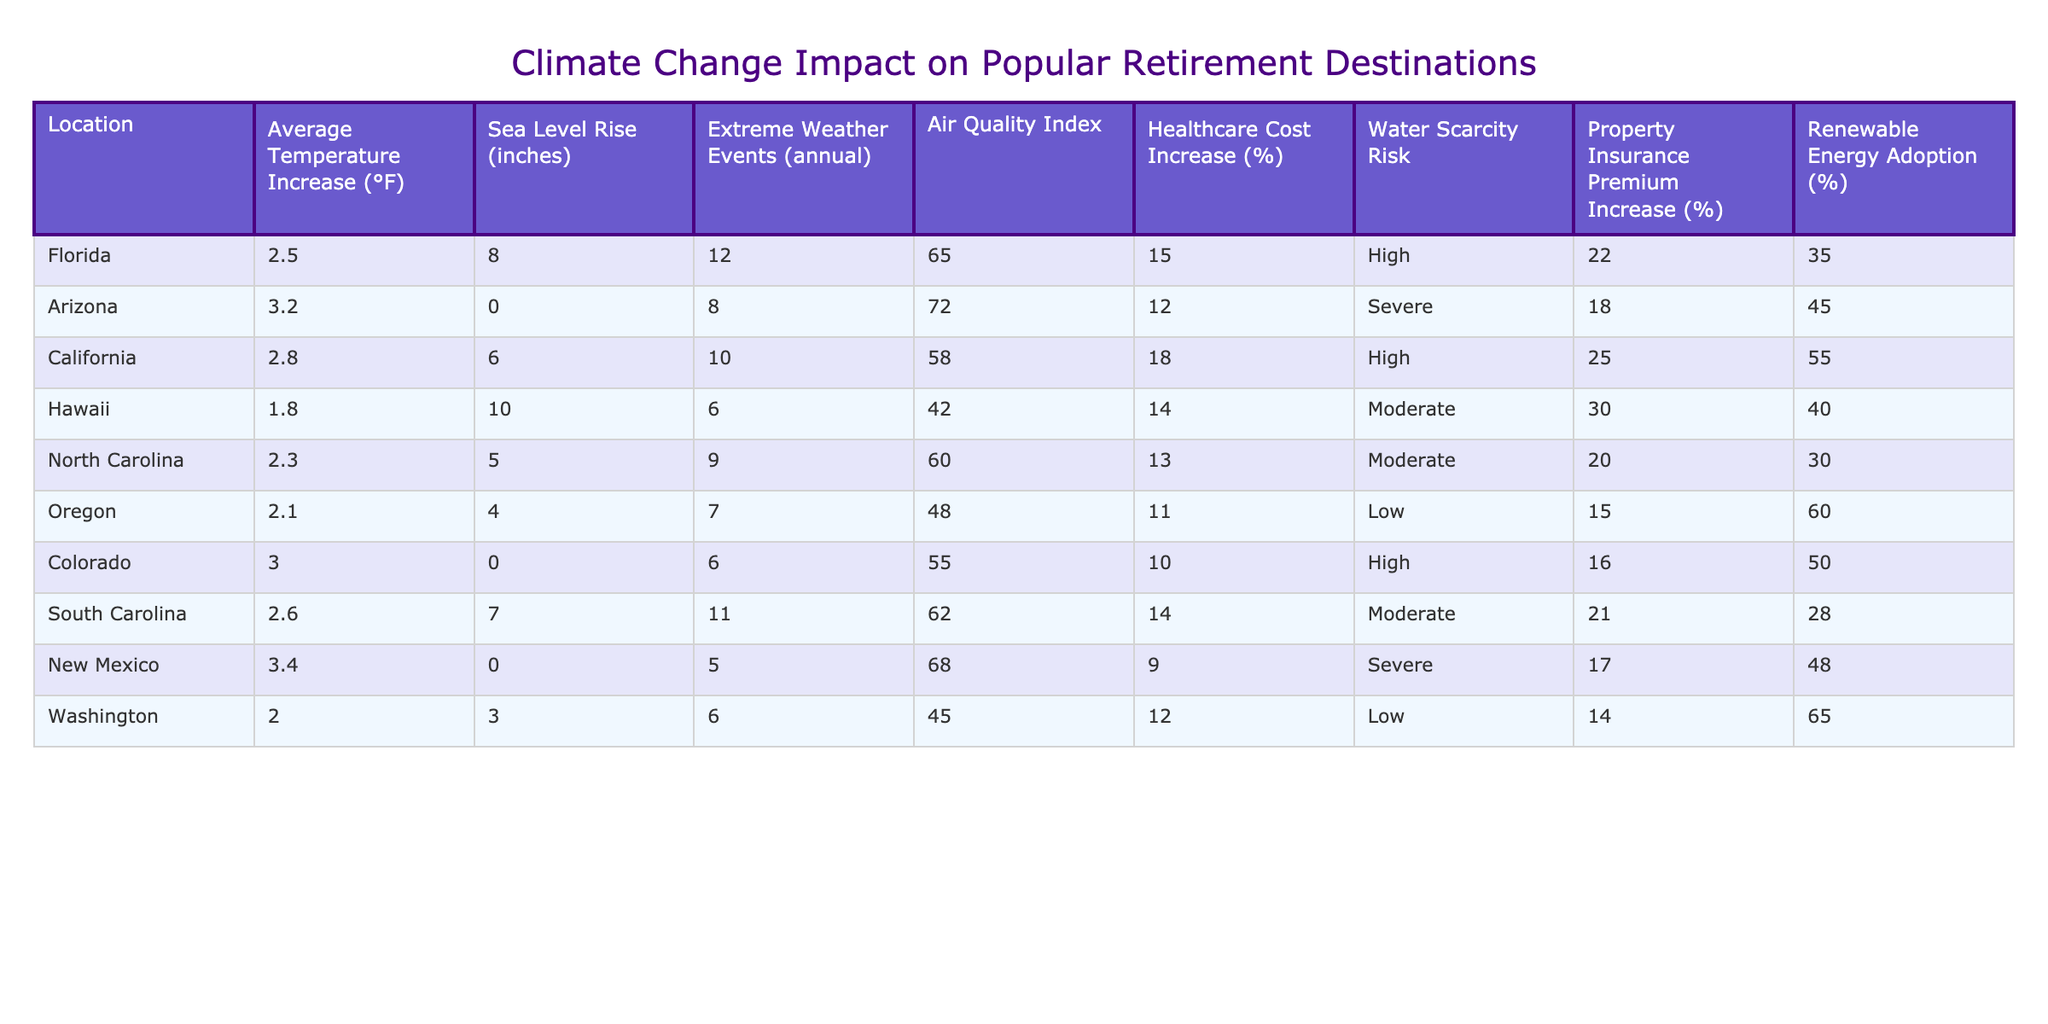What is the average temperature increase in Florida? According to the table, the average temperature increase in Florida is listed directly under the "Average Temperature Increase (°F)" column, which shows a value of 2.5°F.
Answer: 2.5°F Which location has the highest sea level rise? Looking at the "Sea Level Rise (inches)" column, Hawaii has the highest value at 10 inches.
Answer: Hawaii How many extreme weather events occur annually in California? The table shows that California experiences 10 extreme weather events annually, as indicated in the "Extreme Weather Events (annual)" column.
Answer: 10 Is the water scarcity risk in Oregon classified as low? The "Water Scarcity Risk" for Oregon is mentioned as low in the table, confirming that this statement is true.
Answer: Yes What is the difference in average temperature increase between Arizona and Florida? Arizona's average temperature increase is 3.2°F, and Florida's is 2.5°F. The difference is 3.2 - 2.5 = 0.7°F.
Answer: 0.7°F Which two locations have the same healthcare cost increase percentage? By reviewing the "Healthcare Cost Increase (%)" column, both South Carolina and North Carolina have a healthcare cost increase of 14%.
Answer: South Carolina and North Carolina Which location has the highest percentage of renewable energy adoption? Checking the "Renewable Energy Adoption (%)" column, Oregon has the highest adoption rate at 60%.
Answer: Oregon What is the average increase in healthcare costs for all locations combined? Summing the healthcare cost increases: 15 + 12 + 18 + 14 + 13 + 11 + 10 + 14 + 9 = 126. There are 9 locations, therefore the average is 126/9 = 14.
Answer: 14% Which state has the most extreme weather events with a high water scarcity risk? By analyzing the data, Arizona has 8 extreme weather events and is classified as severe in water scarcity risk. This indicates the highest number of events with high risk.
Answer: Arizona What is the total sea level rise for the three states with the highest increases in sea level? The three states with the highest sea level rises are Hawaii (10 inches), Florida (8 inches), and South Carolina (7 inches). Their total is 10 + 8 + 7 = 25 inches.
Answer: 25 inches 